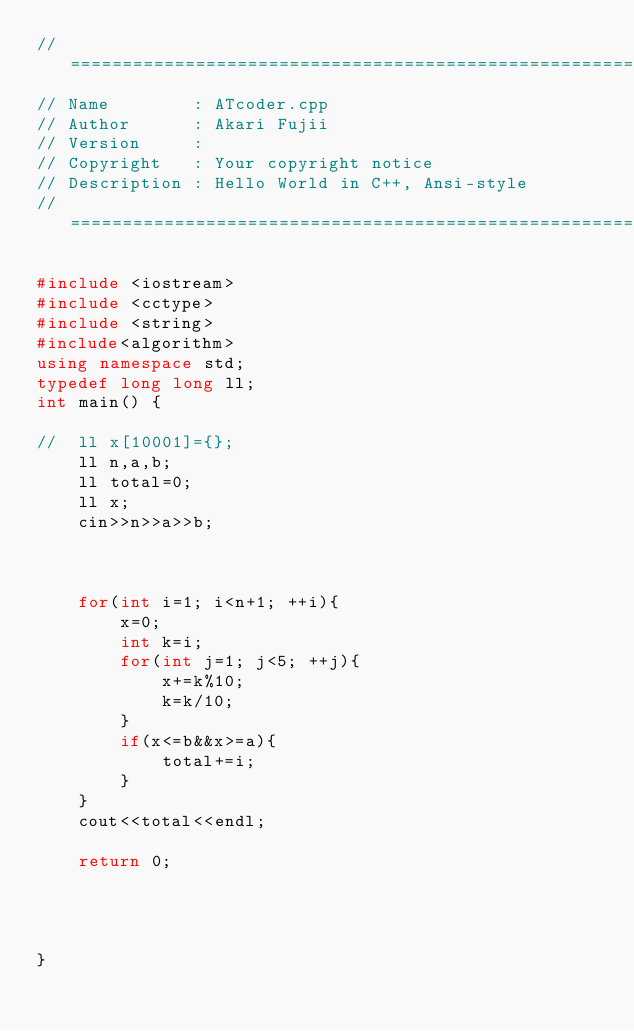<code> <loc_0><loc_0><loc_500><loc_500><_C++_>//============================================================================
// Name        : ATcoder.cpp
// Author      : Akari Fujii
// Version     :
// Copyright   : Your copyright notice
// Description : Hello World in C++, Ansi-style
//============================================================================

#include <iostream>
#include <cctype>
#include <string>
#include<algorithm>
using namespace std;
typedef long long ll;
int main() {

//	ll x[10001]={};
	ll n,a,b;
	ll total=0;
	ll x;
	cin>>n>>a>>b;



	for(int i=1; i<n+1; ++i){
		x=0;
		int k=i;
		for(int j=1; j<5; ++j){
			x+=k%10;
			k=k/10;
		}
		if(x<=b&&x>=a){
			total+=i;
		}
	}
	cout<<total<<endl;

	return 0;




}
</code> 